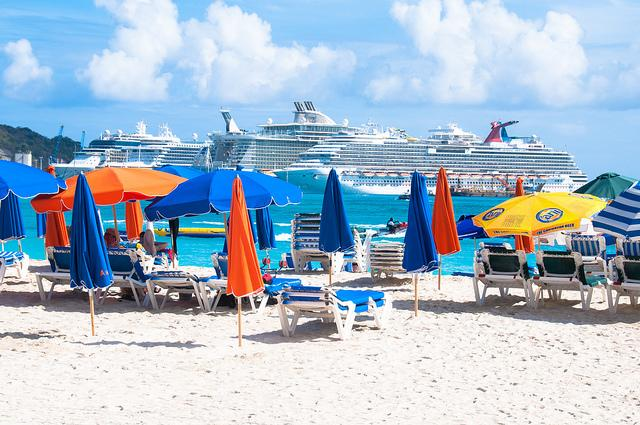What kind of ship is the one in the water? cruise ship 